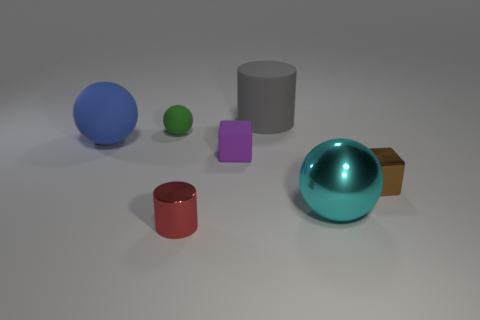Is the color of the sphere on the right side of the red metal thing the same as the tiny matte ball?
Provide a succinct answer. No. How many other things are the same size as the gray thing?
Your answer should be very brief. 2. Does the gray cylinder have the same material as the purple block?
Give a very brief answer. Yes. What is the color of the large object on the right side of the cylinder behind the big blue thing?
Your response must be concise. Cyan. The green matte object that is the same shape as the cyan shiny object is what size?
Provide a short and direct response. Small. Is the shiny ball the same color as the rubber cylinder?
Provide a short and direct response. No. There is a tiny rubber thing behind the matte thing in front of the large blue ball; how many small purple matte objects are in front of it?
Provide a succinct answer. 1. Is the number of big objects greater than the number of tiny blocks?
Give a very brief answer. Yes. How many large cyan metal objects are there?
Offer a very short reply. 1. There is a shiny object that is left of the sphere right of the metal thing that is left of the cyan shiny object; what is its shape?
Keep it short and to the point. Cylinder. 